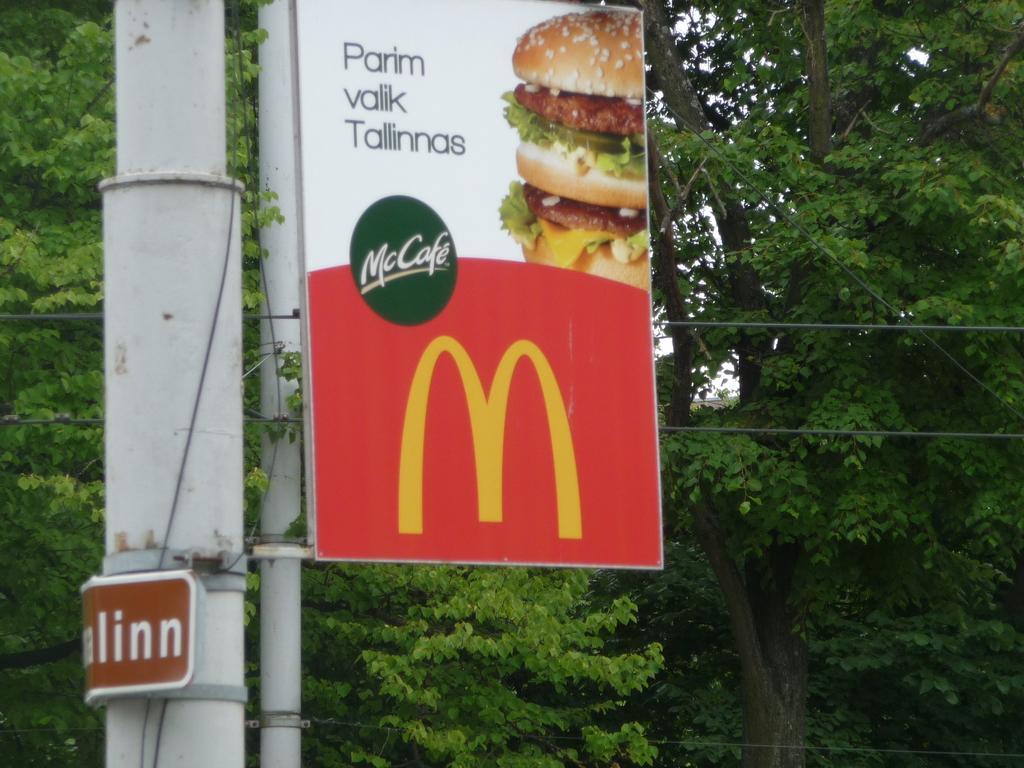Can you describe this image briefly? In this image, we can see a pole with a boarding saying "Parin Walik Tallinas" there is also a symbol of "m" with a background red color and there is also a picture of a burger. At the back of the pole there are some trees. 